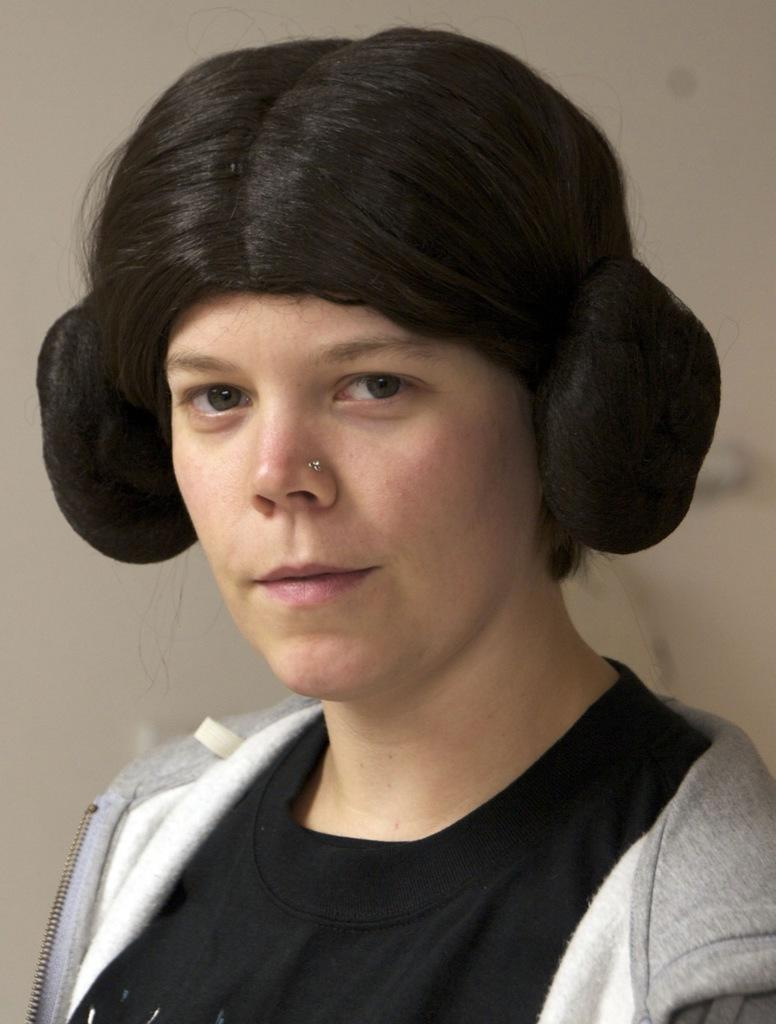What is the main subject of the picture? There is a person in the picture. Can you describe the background of the image? The background of the image is blurred. What type of hammer is the person holding in the image? There is no hammer present in the image; the person is the only subject visible. 